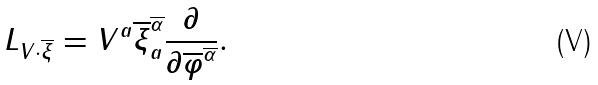<formula> <loc_0><loc_0><loc_500><loc_500>L _ { V \cdot \overline { \xi } } = V ^ { a } \overline { \xi } ^ { \overline { \alpha } } _ { a } \frac { \partial } { \partial \overline { \varphi } ^ { \overline { \alpha } } } .</formula> 